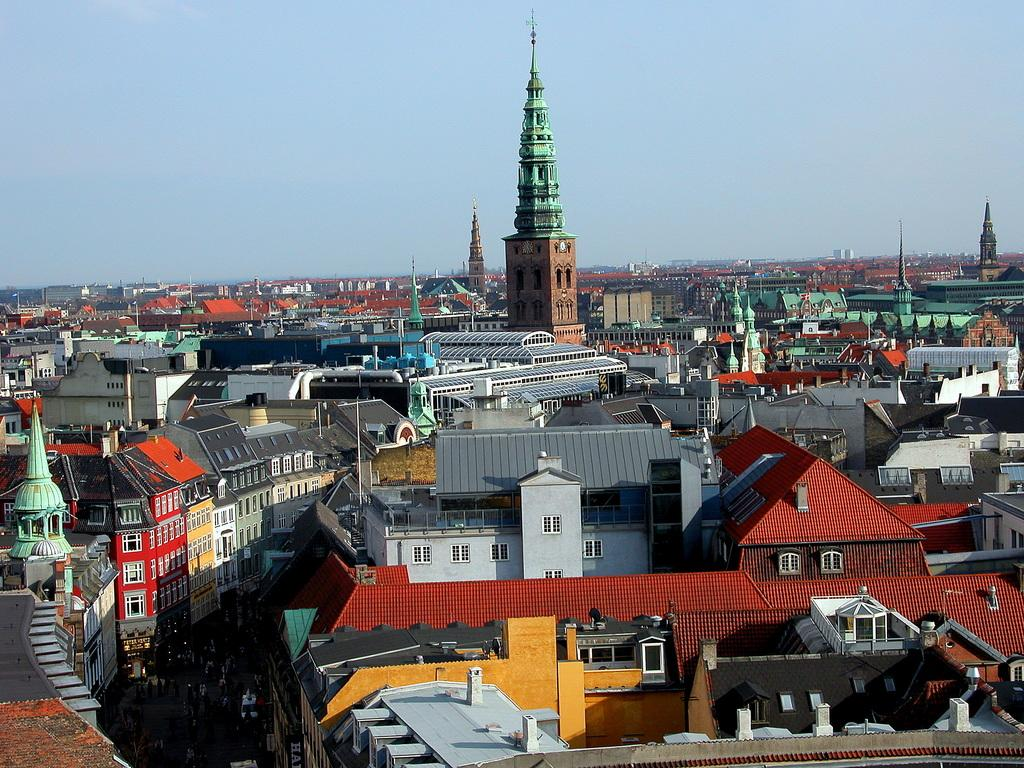What is the main subject of the image? The main subject of the image is many buildings. Can you describe the appearance of the buildings? The buildings are in multiple colors. What can be seen in the background of the image? The sky is visible in the background of the image. What is the color of the sky? The color of the sky is blue. How many ants can be seen crawling on the buildings in the image? There are no ants present in the image; it features buildings and a blue sky. What type of chickens are visible on the roofs of the buildings in the image? There are no chickens present on the roofs of the buildings in the image. 